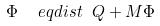<formula> <loc_0><loc_0><loc_500><loc_500>\Phi \ \ e q d i s t \ Q + M \Phi</formula> 